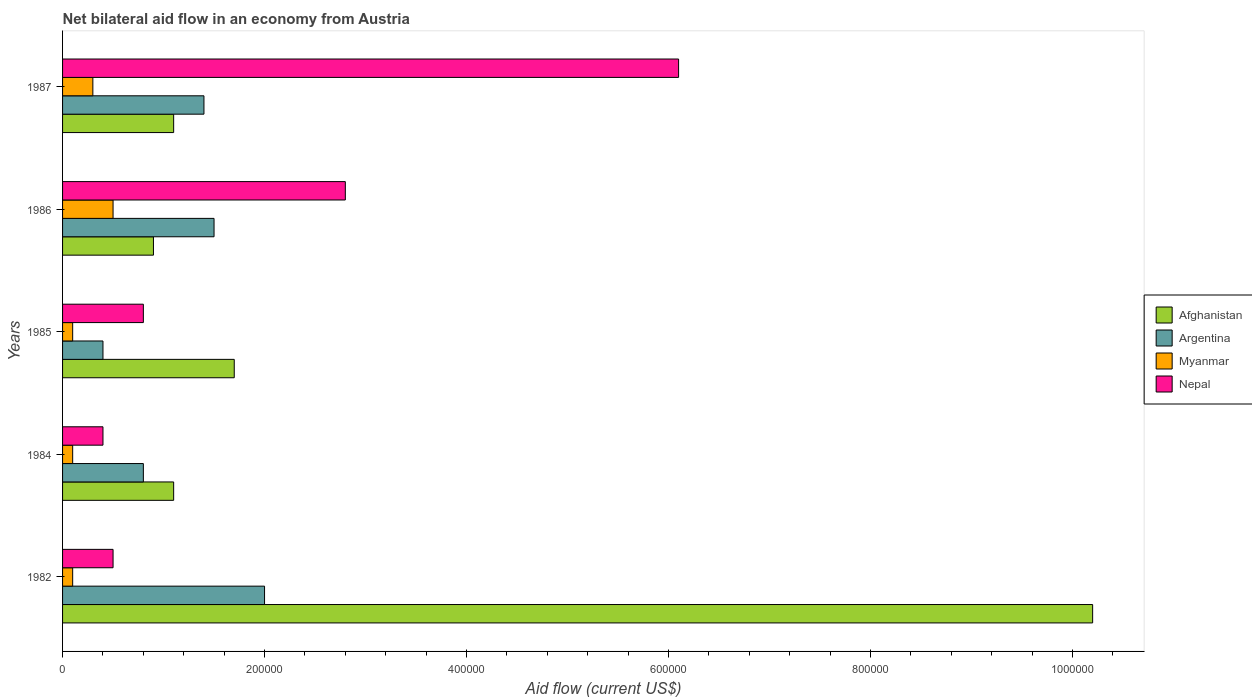How many different coloured bars are there?
Your response must be concise. 4. How many groups of bars are there?
Make the answer very short. 5. Are the number of bars per tick equal to the number of legend labels?
Ensure brevity in your answer.  Yes. Are the number of bars on each tick of the Y-axis equal?
Offer a very short reply. Yes. What is the label of the 4th group of bars from the top?
Provide a succinct answer. 1984. In how many cases, is the number of bars for a given year not equal to the number of legend labels?
Make the answer very short. 0. What is the net bilateral aid flow in Argentina in 1986?
Provide a short and direct response. 1.50e+05. Across all years, what is the maximum net bilateral aid flow in Myanmar?
Provide a succinct answer. 5.00e+04. In which year was the net bilateral aid flow in Afghanistan maximum?
Give a very brief answer. 1982. What is the total net bilateral aid flow in Myanmar in the graph?
Provide a succinct answer. 1.10e+05. What is the difference between the net bilateral aid flow in Nepal in 1987 and the net bilateral aid flow in Afghanistan in 1986?
Keep it short and to the point. 5.20e+05. What is the average net bilateral aid flow in Nepal per year?
Give a very brief answer. 2.12e+05. In the year 1987, what is the difference between the net bilateral aid flow in Afghanistan and net bilateral aid flow in Myanmar?
Ensure brevity in your answer.  8.00e+04. What is the ratio of the net bilateral aid flow in Afghanistan in 1982 to that in 1985?
Offer a terse response. 6. Is the net bilateral aid flow in Argentina in 1985 less than that in 1986?
Your answer should be very brief. Yes. Is the difference between the net bilateral aid flow in Afghanistan in 1982 and 1984 greater than the difference between the net bilateral aid flow in Myanmar in 1982 and 1984?
Ensure brevity in your answer.  Yes. What is the difference between the highest and the second highest net bilateral aid flow in Nepal?
Your response must be concise. 3.30e+05. In how many years, is the net bilateral aid flow in Argentina greater than the average net bilateral aid flow in Argentina taken over all years?
Your response must be concise. 3. Is the sum of the net bilateral aid flow in Afghanistan in 1982 and 1984 greater than the maximum net bilateral aid flow in Myanmar across all years?
Provide a succinct answer. Yes. Is it the case that in every year, the sum of the net bilateral aid flow in Afghanistan and net bilateral aid flow in Myanmar is greater than the sum of net bilateral aid flow in Argentina and net bilateral aid flow in Nepal?
Provide a short and direct response. Yes. What does the 2nd bar from the top in 1985 represents?
Ensure brevity in your answer.  Myanmar. What does the 3rd bar from the bottom in 1986 represents?
Ensure brevity in your answer.  Myanmar. Are all the bars in the graph horizontal?
Provide a succinct answer. Yes. How many years are there in the graph?
Provide a succinct answer. 5. Are the values on the major ticks of X-axis written in scientific E-notation?
Make the answer very short. No. Where does the legend appear in the graph?
Provide a short and direct response. Center right. How many legend labels are there?
Your response must be concise. 4. How are the legend labels stacked?
Make the answer very short. Vertical. What is the title of the graph?
Offer a very short reply. Net bilateral aid flow in an economy from Austria. Does "Liechtenstein" appear as one of the legend labels in the graph?
Make the answer very short. No. What is the label or title of the X-axis?
Ensure brevity in your answer.  Aid flow (current US$). What is the label or title of the Y-axis?
Keep it short and to the point. Years. What is the Aid flow (current US$) in Afghanistan in 1982?
Offer a very short reply. 1.02e+06. What is the Aid flow (current US$) in Afghanistan in 1985?
Your answer should be compact. 1.70e+05. What is the Aid flow (current US$) of Argentina in 1985?
Ensure brevity in your answer.  4.00e+04. What is the Aid flow (current US$) of Myanmar in 1985?
Make the answer very short. 10000. What is the Aid flow (current US$) in Nepal in 1985?
Offer a very short reply. 8.00e+04. What is the Aid flow (current US$) of Myanmar in 1986?
Your response must be concise. 5.00e+04. What is the Aid flow (current US$) in Nepal in 1986?
Give a very brief answer. 2.80e+05. What is the Aid flow (current US$) of Afghanistan in 1987?
Make the answer very short. 1.10e+05. What is the Aid flow (current US$) of Argentina in 1987?
Offer a very short reply. 1.40e+05. What is the Aid flow (current US$) of Myanmar in 1987?
Your response must be concise. 3.00e+04. What is the Aid flow (current US$) in Nepal in 1987?
Your answer should be very brief. 6.10e+05. Across all years, what is the maximum Aid flow (current US$) in Afghanistan?
Your answer should be very brief. 1.02e+06. Across all years, what is the minimum Aid flow (current US$) of Afghanistan?
Keep it short and to the point. 9.00e+04. What is the total Aid flow (current US$) in Afghanistan in the graph?
Make the answer very short. 1.50e+06. What is the total Aid flow (current US$) of Argentina in the graph?
Offer a very short reply. 6.10e+05. What is the total Aid flow (current US$) in Nepal in the graph?
Your answer should be very brief. 1.06e+06. What is the difference between the Aid flow (current US$) of Afghanistan in 1982 and that in 1984?
Make the answer very short. 9.10e+05. What is the difference between the Aid flow (current US$) in Afghanistan in 1982 and that in 1985?
Your answer should be very brief. 8.50e+05. What is the difference between the Aid flow (current US$) in Myanmar in 1982 and that in 1985?
Your answer should be compact. 0. What is the difference between the Aid flow (current US$) of Nepal in 1982 and that in 1985?
Ensure brevity in your answer.  -3.00e+04. What is the difference between the Aid flow (current US$) in Afghanistan in 1982 and that in 1986?
Offer a very short reply. 9.30e+05. What is the difference between the Aid flow (current US$) of Myanmar in 1982 and that in 1986?
Your response must be concise. -4.00e+04. What is the difference between the Aid flow (current US$) in Afghanistan in 1982 and that in 1987?
Provide a succinct answer. 9.10e+05. What is the difference between the Aid flow (current US$) in Argentina in 1982 and that in 1987?
Your answer should be very brief. 6.00e+04. What is the difference between the Aid flow (current US$) in Nepal in 1982 and that in 1987?
Ensure brevity in your answer.  -5.60e+05. What is the difference between the Aid flow (current US$) of Argentina in 1984 and that in 1985?
Your answer should be very brief. 4.00e+04. What is the difference between the Aid flow (current US$) of Myanmar in 1984 and that in 1985?
Provide a short and direct response. 0. What is the difference between the Aid flow (current US$) of Nepal in 1984 and that in 1985?
Make the answer very short. -4.00e+04. What is the difference between the Aid flow (current US$) of Afghanistan in 1984 and that in 1986?
Provide a succinct answer. 2.00e+04. What is the difference between the Aid flow (current US$) of Myanmar in 1984 and that in 1986?
Your answer should be compact. -4.00e+04. What is the difference between the Aid flow (current US$) of Nepal in 1984 and that in 1986?
Ensure brevity in your answer.  -2.40e+05. What is the difference between the Aid flow (current US$) of Afghanistan in 1984 and that in 1987?
Your answer should be very brief. 0. What is the difference between the Aid flow (current US$) in Myanmar in 1984 and that in 1987?
Your answer should be very brief. -2.00e+04. What is the difference between the Aid flow (current US$) of Nepal in 1984 and that in 1987?
Provide a short and direct response. -5.70e+05. What is the difference between the Aid flow (current US$) of Afghanistan in 1985 and that in 1986?
Give a very brief answer. 8.00e+04. What is the difference between the Aid flow (current US$) of Argentina in 1985 and that in 1986?
Make the answer very short. -1.10e+05. What is the difference between the Aid flow (current US$) of Myanmar in 1985 and that in 1986?
Ensure brevity in your answer.  -4.00e+04. What is the difference between the Aid flow (current US$) in Argentina in 1985 and that in 1987?
Offer a terse response. -1.00e+05. What is the difference between the Aid flow (current US$) in Myanmar in 1985 and that in 1987?
Keep it short and to the point. -2.00e+04. What is the difference between the Aid flow (current US$) of Nepal in 1985 and that in 1987?
Give a very brief answer. -5.30e+05. What is the difference between the Aid flow (current US$) in Afghanistan in 1986 and that in 1987?
Provide a succinct answer. -2.00e+04. What is the difference between the Aid flow (current US$) of Argentina in 1986 and that in 1987?
Provide a succinct answer. 10000. What is the difference between the Aid flow (current US$) in Nepal in 1986 and that in 1987?
Provide a succinct answer. -3.30e+05. What is the difference between the Aid flow (current US$) of Afghanistan in 1982 and the Aid flow (current US$) of Argentina in 1984?
Your answer should be very brief. 9.40e+05. What is the difference between the Aid flow (current US$) in Afghanistan in 1982 and the Aid flow (current US$) in Myanmar in 1984?
Make the answer very short. 1.01e+06. What is the difference between the Aid flow (current US$) in Afghanistan in 1982 and the Aid flow (current US$) in Nepal in 1984?
Provide a short and direct response. 9.80e+05. What is the difference between the Aid flow (current US$) of Afghanistan in 1982 and the Aid flow (current US$) of Argentina in 1985?
Provide a short and direct response. 9.80e+05. What is the difference between the Aid flow (current US$) of Afghanistan in 1982 and the Aid flow (current US$) of Myanmar in 1985?
Keep it short and to the point. 1.01e+06. What is the difference between the Aid flow (current US$) in Afghanistan in 1982 and the Aid flow (current US$) in Nepal in 1985?
Offer a very short reply. 9.40e+05. What is the difference between the Aid flow (current US$) in Argentina in 1982 and the Aid flow (current US$) in Myanmar in 1985?
Keep it short and to the point. 1.90e+05. What is the difference between the Aid flow (current US$) in Argentina in 1982 and the Aid flow (current US$) in Nepal in 1985?
Make the answer very short. 1.20e+05. What is the difference between the Aid flow (current US$) of Myanmar in 1982 and the Aid flow (current US$) of Nepal in 1985?
Give a very brief answer. -7.00e+04. What is the difference between the Aid flow (current US$) in Afghanistan in 1982 and the Aid flow (current US$) in Argentina in 1986?
Ensure brevity in your answer.  8.70e+05. What is the difference between the Aid flow (current US$) of Afghanistan in 1982 and the Aid flow (current US$) of Myanmar in 1986?
Give a very brief answer. 9.70e+05. What is the difference between the Aid flow (current US$) of Afghanistan in 1982 and the Aid flow (current US$) of Nepal in 1986?
Make the answer very short. 7.40e+05. What is the difference between the Aid flow (current US$) of Myanmar in 1982 and the Aid flow (current US$) of Nepal in 1986?
Make the answer very short. -2.70e+05. What is the difference between the Aid flow (current US$) of Afghanistan in 1982 and the Aid flow (current US$) of Argentina in 1987?
Provide a short and direct response. 8.80e+05. What is the difference between the Aid flow (current US$) of Afghanistan in 1982 and the Aid flow (current US$) of Myanmar in 1987?
Your answer should be very brief. 9.90e+05. What is the difference between the Aid flow (current US$) in Afghanistan in 1982 and the Aid flow (current US$) in Nepal in 1987?
Make the answer very short. 4.10e+05. What is the difference between the Aid flow (current US$) of Argentina in 1982 and the Aid flow (current US$) of Myanmar in 1987?
Provide a short and direct response. 1.70e+05. What is the difference between the Aid flow (current US$) in Argentina in 1982 and the Aid flow (current US$) in Nepal in 1987?
Your answer should be compact. -4.10e+05. What is the difference between the Aid flow (current US$) of Myanmar in 1982 and the Aid flow (current US$) of Nepal in 1987?
Make the answer very short. -6.00e+05. What is the difference between the Aid flow (current US$) in Argentina in 1984 and the Aid flow (current US$) in Myanmar in 1985?
Make the answer very short. 7.00e+04. What is the difference between the Aid flow (current US$) of Afghanistan in 1984 and the Aid flow (current US$) of Myanmar in 1986?
Your answer should be compact. 6.00e+04. What is the difference between the Aid flow (current US$) in Myanmar in 1984 and the Aid flow (current US$) in Nepal in 1986?
Offer a very short reply. -2.70e+05. What is the difference between the Aid flow (current US$) of Afghanistan in 1984 and the Aid flow (current US$) of Argentina in 1987?
Provide a succinct answer. -3.00e+04. What is the difference between the Aid flow (current US$) of Afghanistan in 1984 and the Aid flow (current US$) of Myanmar in 1987?
Your answer should be very brief. 8.00e+04. What is the difference between the Aid flow (current US$) of Afghanistan in 1984 and the Aid flow (current US$) of Nepal in 1987?
Provide a succinct answer. -5.00e+05. What is the difference between the Aid flow (current US$) of Argentina in 1984 and the Aid flow (current US$) of Myanmar in 1987?
Your response must be concise. 5.00e+04. What is the difference between the Aid flow (current US$) in Argentina in 1984 and the Aid flow (current US$) in Nepal in 1987?
Offer a very short reply. -5.30e+05. What is the difference between the Aid flow (current US$) in Myanmar in 1984 and the Aid flow (current US$) in Nepal in 1987?
Provide a succinct answer. -6.00e+05. What is the difference between the Aid flow (current US$) of Afghanistan in 1985 and the Aid flow (current US$) of Myanmar in 1986?
Keep it short and to the point. 1.20e+05. What is the difference between the Aid flow (current US$) of Afghanistan in 1985 and the Aid flow (current US$) of Nepal in 1986?
Give a very brief answer. -1.10e+05. What is the difference between the Aid flow (current US$) of Myanmar in 1985 and the Aid flow (current US$) of Nepal in 1986?
Offer a terse response. -2.70e+05. What is the difference between the Aid flow (current US$) of Afghanistan in 1985 and the Aid flow (current US$) of Argentina in 1987?
Provide a succinct answer. 3.00e+04. What is the difference between the Aid flow (current US$) in Afghanistan in 1985 and the Aid flow (current US$) in Nepal in 1987?
Provide a short and direct response. -4.40e+05. What is the difference between the Aid flow (current US$) of Argentina in 1985 and the Aid flow (current US$) of Myanmar in 1987?
Ensure brevity in your answer.  10000. What is the difference between the Aid flow (current US$) in Argentina in 1985 and the Aid flow (current US$) in Nepal in 1987?
Keep it short and to the point. -5.70e+05. What is the difference between the Aid flow (current US$) in Myanmar in 1985 and the Aid flow (current US$) in Nepal in 1987?
Provide a short and direct response. -6.00e+05. What is the difference between the Aid flow (current US$) of Afghanistan in 1986 and the Aid flow (current US$) of Argentina in 1987?
Your answer should be compact. -5.00e+04. What is the difference between the Aid flow (current US$) in Afghanistan in 1986 and the Aid flow (current US$) in Myanmar in 1987?
Make the answer very short. 6.00e+04. What is the difference between the Aid flow (current US$) of Afghanistan in 1986 and the Aid flow (current US$) of Nepal in 1987?
Offer a very short reply. -5.20e+05. What is the difference between the Aid flow (current US$) of Argentina in 1986 and the Aid flow (current US$) of Nepal in 1987?
Make the answer very short. -4.60e+05. What is the difference between the Aid flow (current US$) of Myanmar in 1986 and the Aid flow (current US$) of Nepal in 1987?
Give a very brief answer. -5.60e+05. What is the average Aid flow (current US$) of Afghanistan per year?
Your answer should be compact. 3.00e+05. What is the average Aid flow (current US$) in Argentina per year?
Your answer should be compact. 1.22e+05. What is the average Aid flow (current US$) in Myanmar per year?
Make the answer very short. 2.20e+04. What is the average Aid flow (current US$) of Nepal per year?
Make the answer very short. 2.12e+05. In the year 1982, what is the difference between the Aid flow (current US$) of Afghanistan and Aid flow (current US$) of Argentina?
Provide a short and direct response. 8.20e+05. In the year 1982, what is the difference between the Aid flow (current US$) in Afghanistan and Aid flow (current US$) in Myanmar?
Give a very brief answer. 1.01e+06. In the year 1982, what is the difference between the Aid flow (current US$) of Afghanistan and Aid flow (current US$) of Nepal?
Your answer should be compact. 9.70e+05. In the year 1982, what is the difference between the Aid flow (current US$) of Argentina and Aid flow (current US$) of Nepal?
Your answer should be compact. 1.50e+05. In the year 1984, what is the difference between the Aid flow (current US$) in Afghanistan and Aid flow (current US$) in Argentina?
Provide a succinct answer. 3.00e+04. In the year 1984, what is the difference between the Aid flow (current US$) in Afghanistan and Aid flow (current US$) in Myanmar?
Provide a succinct answer. 1.00e+05. In the year 1984, what is the difference between the Aid flow (current US$) of Myanmar and Aid flow (current US$) of Nepal?
Provide a succinct answer. -3.00e+04. In the year 1985, what is the difference between the Aid flow (current US$) in Afghanistan and Aid flow (current US$) in Myanmar?
Give a very brief answer. 1.60e+05. In the year 1985, what is the difference between the Aid flow (current US$) of Argentina and Aid flow (current US$) of Myanmar?
Ensure brevity in your answer.  3.00e+04. In the year 1985, what is the difference between the Aid flow (current US$) in Myanmar and Aid flow (current US$) in Nepal?
Your answer should be compact. -7.00e+04. In the year 1986, what is the difference between the Aid flow (current US$) of Afghanistan and Aid flow (current US$) of Myanmar?
Provide a short and direct response. 4.00e+04. In the year 1986, what is the difference between the Aid flow (current US$) in Argentina and Aid flow (current US$) in Myanmar?
Offer a terse response. 1.00e+05. In the year 1987, what is the difference between the Aid flow (current US$) in Afghanistan and Aid flow (current US$) in Nepal?
Keep it short and to the point. -5.00e+05. In the year 1987, what is the difference between the Aid flow (current US$) of Argentina and Aid flow (current US$) of Nepal?
Offer a terse response. -4.70e+05. In the year 1987, what is the difference between the Aid flow (current US$) of Myanmar and Aid flow (current US$) of Nepal?
Your answer should be compact. -5.80e+05. What is the ratio of the Aid flow (current US$) of Afghanistan in 1982 to that in 1984?
Your response must be concise. 9.27. What is the ratio of the Aid flow (current US$) of Argentina in 1982 to that in 1984?
Provide a succinct answer. 2.5. What is the ratio of the Aid flow (current US$) in Nepal in 1982 to that in 1984?
Make the answer very short. 1.25. What is the ratio of the Aid flow (current US$) of Afghanistan in 1982 to that in 1985?
Provide a succinct answer. 6. What is the ratio of the Aid flow (current US$) of Argentina in 1982 to that in 1985?
Ensure brevity in your answer.  5. What is the ratio of the Aid flow (current US$) in Nepal in 1982 to that in 1985?
Make the answer very short. 0.62. What is the ratio of the Aid flow (current US$) of Afghanistan in 1982 to that in 1986?
Offer a terse response. 11.33. What is the ratio of the Aid flow (current US$) in Nepal in 1982 to that in 1986?
Your response must be concise. 0.18. What is the ratio of the Aid flow (current US$) of Afghanistan in 1982 to that in 1987?
Offer a terse response. 9.27. What is the ratio of the Aid flow (current US$) in Argentina in 1982 to that in 1987?
Your response must be concise. 1.43. What is the ratio of the Aid flow (current US$) of Nepal in 1982 to that in 1987?
Your answer should be compact. 0.08. What is the ratio of the Aid flow (current US$) in Afghanistan in 1984 to that in 1985?
Ensure brevity in your answer.  0.65. What is the ratio of the Aid flow (current US$) in Myanmar in 1984 to that in 1985?
Give a very brief answer. 1. What is the ratio of the Aid flow (current US$) in Afghanistan in 1984 to that in 1986?
Make the answer very short. 1.22. What is the ratio of the Aid flow (current US$) of Argentina in 1984 to that in 1986?
Provide a short and direct response. 0.53. What is the ratio of the Aid flow (current US$) in Myanmar in 1984 to that in 1986?
Your answer should be very brief. 0.2. What is the ratio of the Aid flow (current US$) of Nepal in 1984 to that in 1986?
Offer a terse response. 0.14. What is the ratio of the Aid flow (current US$) of Nepal in 1984 to that in 1987?
Keep it short and to the point. 0.07. What is the ratio of the Aid flow (current US$) of Afghanistan in 1985 to that in 1986?
Ensure brevity in your answer.  1.89. What is the ratio of the Aid flow (current US$) in Argentina in 1985 to that in 1986?
Ensure brevity in your answer.  0.27. What is the ratio of the Aid flow (current US$) in Myanmar in 1985 to that in 1986?
Offer a very short reply. 0.2. What is the ratio of the Aid flow (current US$) in Nepal in 1985 to that in 1986?
Your response must be concise. 0.29. What is the ratio of the Aid flow (current US$) of Afghanistan in 1985 to that in 1987?
Your answer should be very brief. 1.55. What is the ratio of the Aid flow (current US$) in Argentina in 1985 to that in 1987?
Make the answer very short. 0.29. What is the ratio of the Aid flow (current US$) of Nepal in 1985 to that in 1987?
Offer a very short reply. 0.13. What is the ratio of the Aid flow (current US$) of Afghanistan in 1986 to that in 1987?
Make the answer very short. 0.82. What is the ratio of the Aid flow (current US$) of Argentina in 1986 to that in 1987?
Your answer should be compact. 1.07. What is the ratio of the Aid flow (current US$) in Nepal in 1986 to that in 1987?
Your answer should be compact. 0.46. What is the difference between the highest and the second highest Aid flow (current US$) in Afghanistan?
Keep it short and to the point. 8.50e+05. What is the difference between the highest and the second highest Aid flow (current US$) in Nepal?
Provide a short and direct response. 3.30e+05. What is the difference between the highest and the lowest Aid flow (current US$) in Afghanistan?
Provide a succinct answer. 9.30e+05. What is the difference between the highest and the lowest Aid flow (current US$) in Argentina?
Your answer should be compact. 1.60e+05. What is the difference between the highest and the lowest Aid flow (current US$) in Myanmar?
Provide a short and direct response. 4.00e+04. What is the difference between the highest and the lowest Aid flow (current US$) in Nepal?
Provide a short and direct response. 5.70e+05. 